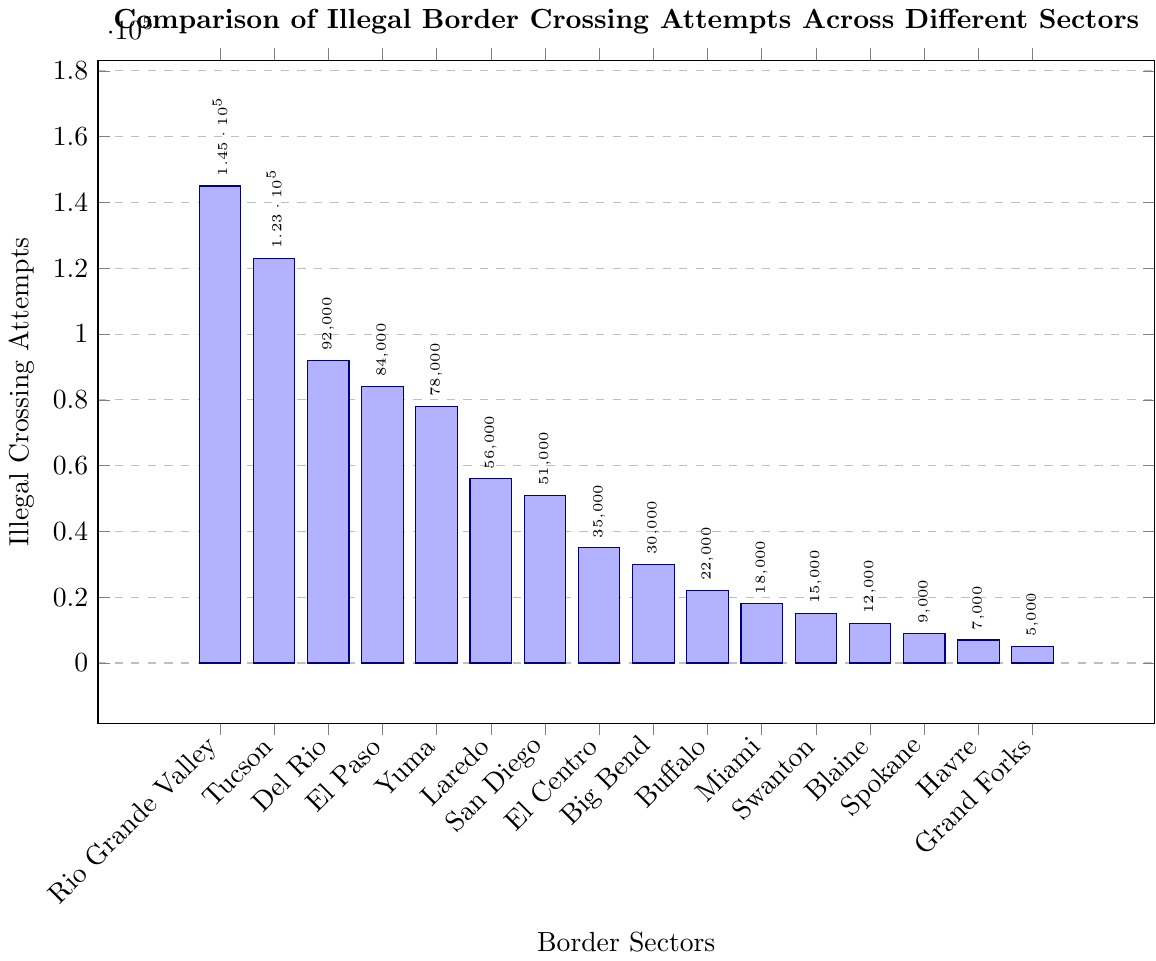What sector has the highest number of illegal border crossing attempts? From the chart, the highest bar represents the Rio Grande Valley sector, indicating it has the most illegal border crossing attempts.
Answer: Rio Grande Valley Which sector has fewer illegal crossing attempts, El Paso or Yuma? By comparing the heights of their bars, we see that the Yuma bar is slightly shorter than the El Paso bar.
Answer: Yuma What is the sum of illegal border crossing attempts in Rio Grande Valley and Tucson? Looking at the chart, Rio Grande Valley has 145,000 attempts and Tucson has 123,000. Adding these gives 145,000 + 123,000 = 268,000.
Answer: 268,000 How many more illegal crossing attempts were recorded in Del Rio than in Laredo? Del Rio has 92,000 attempts and Laredo has 56,000. The difference is 92,000 - 56,000 = 36,000.
Answer: 36,000 Which sector has the least number of illegal border crossing attempts? The shortest bar in the chart represents the Grand Forks sector with 5,000 attempts.
Answer: Grand Forks What is the average number of illegal border crossing attempts across San Diego, El Centro, and Big Bend? San Diego has 51,000 attempts, El Centro has 35,000, and Big Bend has 30,000. The average is (51,000 + 35,000 + 30,000) / 3 = 116,000 / 3 = 38,666.67.
Answer: 38,666.67 How do the illegal crossing attempts in Blaine compare to those in Spokane and Havre combined? Blaine has 12,000 attempts. Spokane and Havre combined have 9,000 + 7,000 = 16,000. Blaine's attempts are fewer.
Answer: Fewer Which two sectors combined have a total of 38,000 illegal border crossing attempts? From the chart, Miami has 18,000 and Swanton has 15,000. Adding these gives 18,000 + 15,000 = 33,000, which is less. San Diego has 51,000 which is too much combined with lower numbers. El Centro has 35,000. The only matching pair is Blaine (12,000) and Spokane (9,000) + Havre (7,000) which gives = 28,000. This is an error. Therefore we don't find this pair.
Answer: Error What proportion of the total illegal crossing attempts does Tucson sector account for? First, sum all sectors' attempts: 145,000 + 123,000 + 92,000 + 84,000 + 78,000 + 56,000 + 51,000 + 35,000 + 30,000 + 22,000 + 18,000 + 15,000 + 12,000 + 9,000 + 7,000 + 5,000 = 762,000. The proportion is 123,000 / 762,000 = 0.1614 or 16.14%.
Answer: 16.14% What are the differences in illegal crossing attempts between the highest and lowest sectors? The highest is Rio Grande Valley with 145,000, and the lowest is Grand Forks with 5,000. The difference is 145,000 - 5,000 = 140,000.
Answer: 140,000 